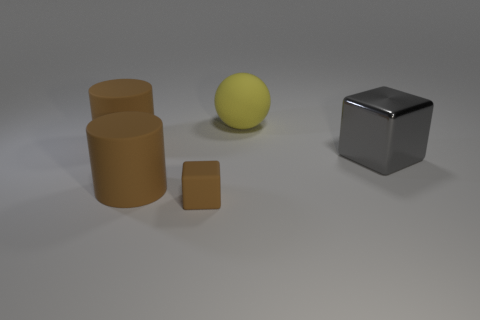Is the large cube the same color as the tiny object?
Make the answer very short. No. Is the number of small brown blocks greater than the number of gray matte cylinders?
Provide a short and direct response. Yes. How many other objects are there of the same material as the tiny object?
Offer a very short reply. 3. What number of things are either tiny rubber blocks or big objects right of the tiny rubber thing?
Provide a short and direct response. 3. Are there fewer small brown matte cylinders than gray objects?
Provide a short and direct response. Yes. What is the color of the thing on the right side of the big yellow sphere that is behind the cube to the right of the small brown block?
Keep it short and to the point. Gray. Do the large yellow thing and the gray thing have the same material?
Offer a very short reply. No. How many big brown rubber cylinders are right of the big yellow matte thing?
Your answer should be very brief. 0. There is a gray shiny thing that is the same shape as the small brown matte thing; what is its size?
Provide a succinct answer. Large. What number of blue objects are either big blocks or cubes?
Your response must be concise. 0. 